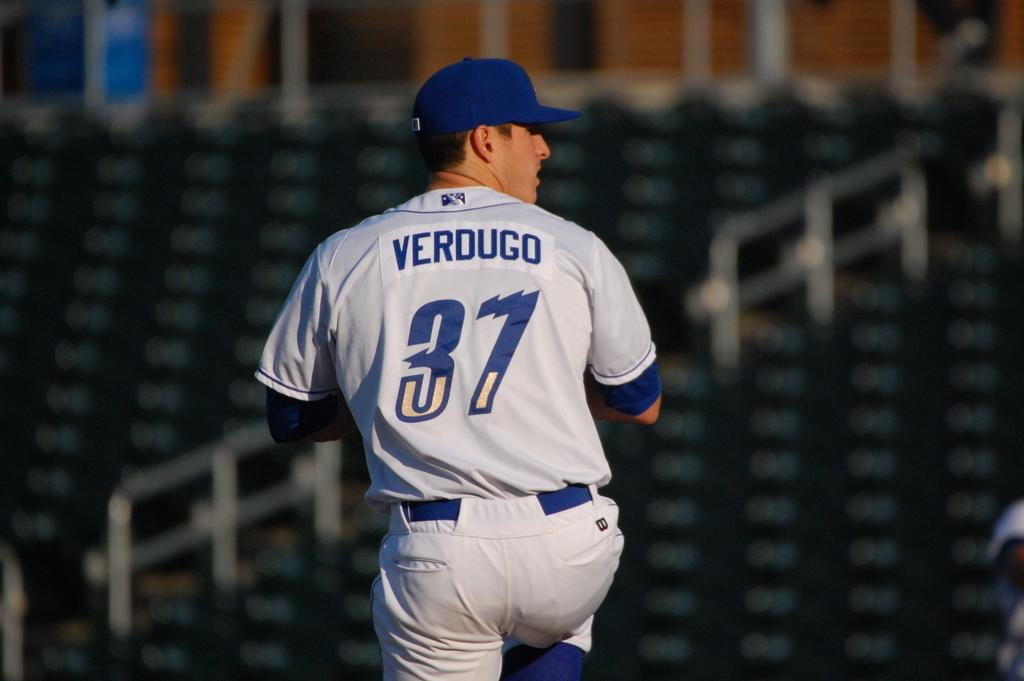<image>
Create a compact narrative representing the image presented. Verdugo is player number 37 on his baseball team. 